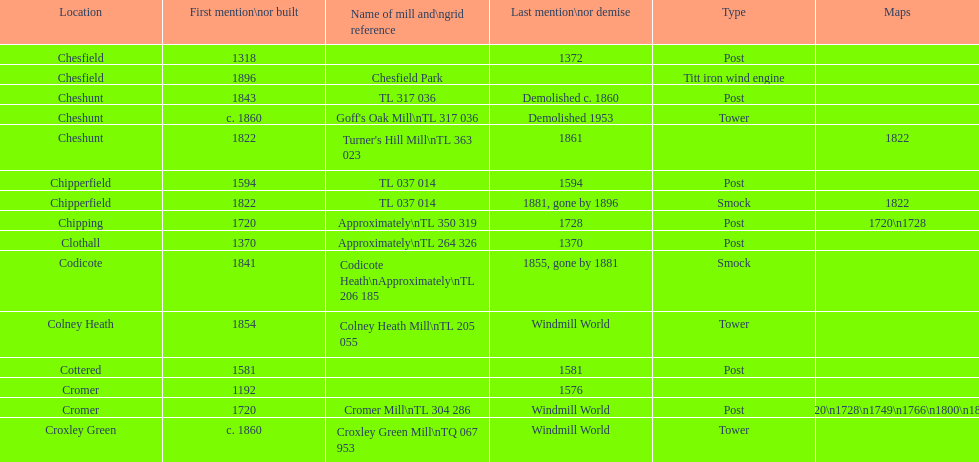How man "c" windmills have there been? 15. Write the full table. {'header': ['Location', 'First mention\\nor built', 'Name of mill and\\ngrid reference', 'Last mention\\nor demise', 'Type', 'Maps'], 'rows': [['Chesfield', '1318', '', '1372', 'Post', ''], ['Chesfield', '1896', 'Chesfield Park', '', 'Titt iron wind engine', ''], ['Cheshunt', '1843', 'TL 317 036', 'Demolished c. 1860', 'Post', ''], ['Cheshunt', 'c. 1860', "Goff's Oak Mill\\nTL 317 036", 'Demolished 1953', 'Tower', ''], ['Cheshunt', '1822', "Turner's Hill Mill\\nTL 363 023", '1861', '', '1822'], ['Chipperfield', '1594', 'TL 037 014', '1594', 'Post', ''], ['Chipperfield', '1822', 'TL 037 014', '1881, gone by 1896', 'Smock', '1822'], ['Chipping', '1720', 'Approximately\\nTL 350 319', '1728', 'Post', '1720\\n1728'], ['Clothall', '1370', 'Approximately\\nTL 264 326', '1370', 'Post', ''], ['Codicote', '1841', 'Codicote Heath\\nApproximately\\nTL 206 185', '1855, gone by 1881', 'Smock', ''], ['Colney Heath', '1854', 'Colney Heath Mill\\nTL 205 055', 'Windmill World', 'Tower', ''], ['Cottered', '1581', '', '1581', 'Post', ''], ['Cromer', '1192', '', '1576', '', ''], ['Cromer', '1720', 'Cromer Mill\\nTL 304 286', 'Windmill World', 'Post', '1720\\n1728\\n1749\\n1766\\n1800\\n1822'], ['Croxley Green', 'c. 1860', 'Croxley Green Mill\\nTQ 067 953', 'Windmill World', 'Tower', '']]} 